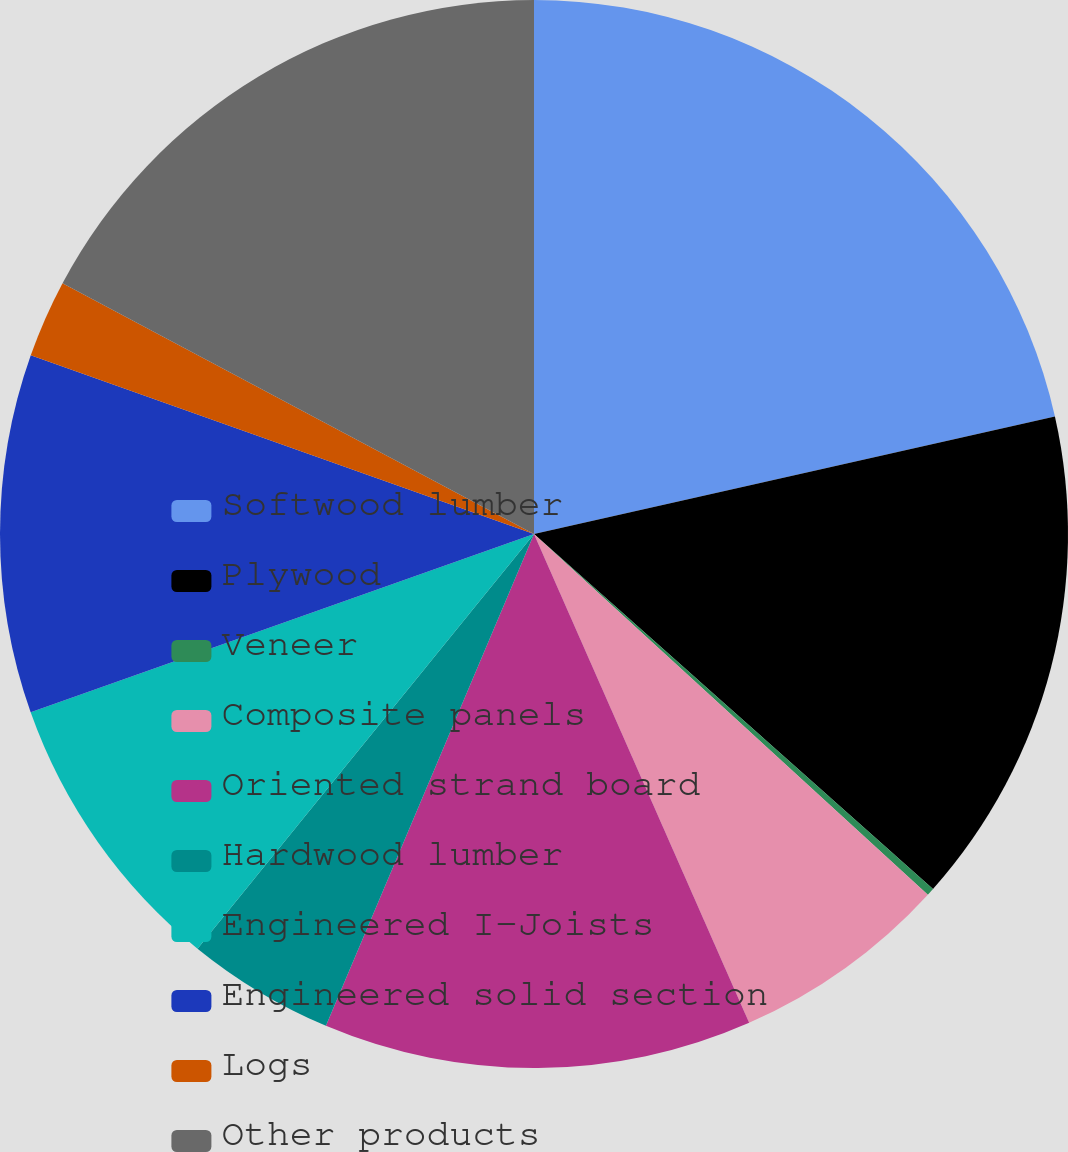<chart> <loc_0><loc_0><loc_500><loc_500><pie_chart><fcel>Softwood lumber<fcel>Plywood<fcel>Veneer<fcel>Composite panels<fcel>Oriented strand board<fcel>Hardwood lumber<fcel>Engineered I-Joists<fcel>Engineered solid section<fcel>Logs<fcel>Other products<nl><fcel>21.47%<fcel>15.1%<fcel>0.23%<fcel>6.6%<fcel>12.97%<fcel>4.48%<fcel>8.73%<fcel>10.85%<fcel>2.35%<fcel>17.22%<nl></chart> 